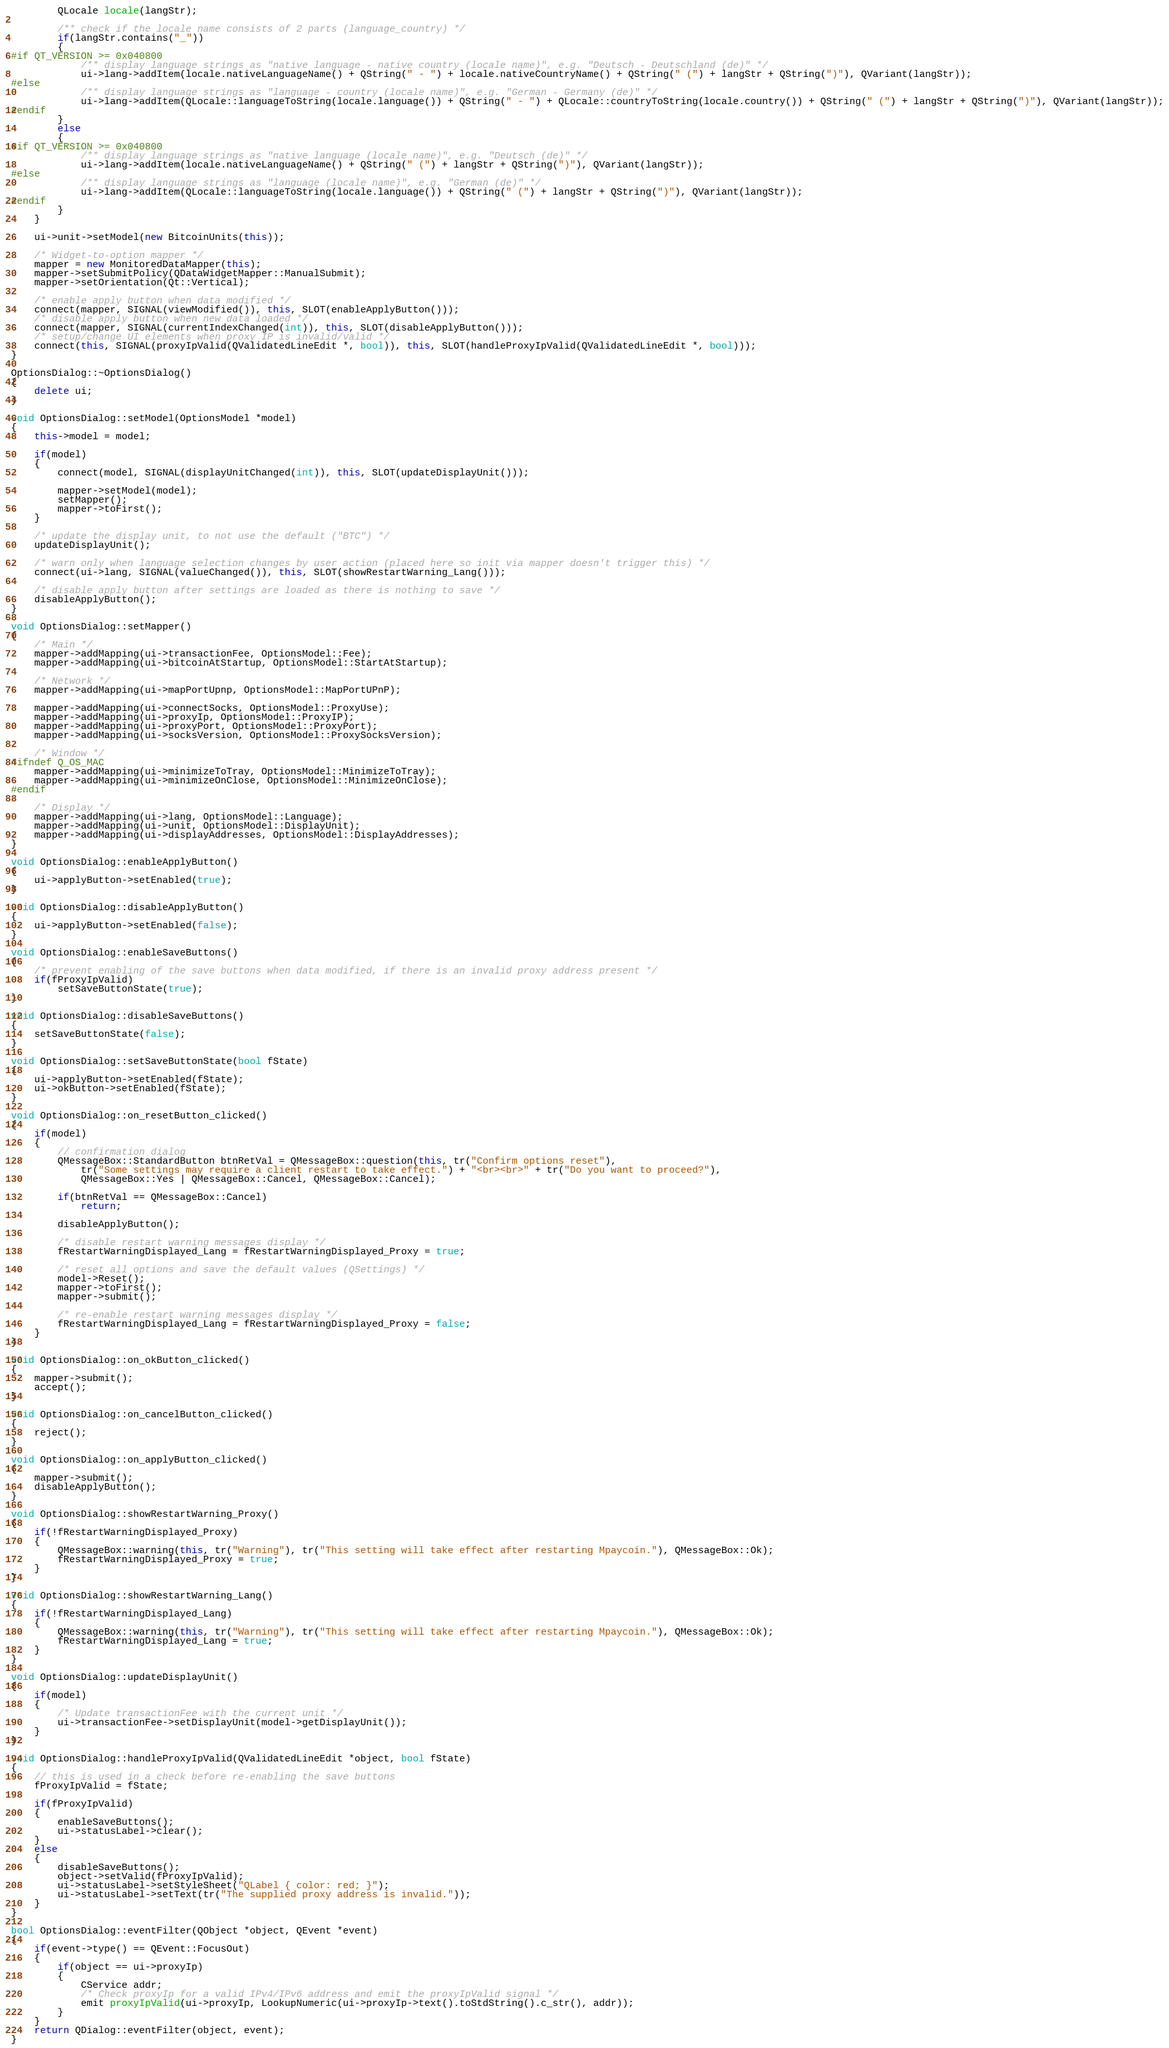<code> <loc_0><loc_0><loc_500><loc_500><_C++_>        QLocale locale(langStr);

        /** check if the locale name consists of 2 parts (language_country) */
        if(langStr.contains("_"))
        {
#if QT_VERSION >= 0x040800
            /** display language strings as "native language - native country (locale name)", e.g. "Deutsch - Deutschland (de)" */
            ui->lang->addItem(locale.nativeLanguageName() + QString(" - ") + locale.nativeCountryName() + QString(" (") + langStr + QString(")"), QVariant(langStr));
#else
            /** display language strings as "language - country (locale name)", e.g. "German - Germany (de)" */
            ui->lang->addItem(QLocale::languageToString(locale.language()) + QString(" - ") + QLocale::countryToString(locale.country()) + QString(" (") + langStr + QString(")"), QVariant(langStr));
#endif
        }
        else
        {
#if QT_VERSION >= 0x040800
            /** display language strings as "native language (locale name)", e.g. "Deutsch (de)" */
            ui->lang->addItem(locale.nativeLanguageName() + QString(" (") + langStr + QString(")"), QVariant(langStr));
#else
            /** display language strings as "language (locale name)", e.g. "German (de)" */
            ui->lang->addItem(QLocale::languageToString(locale.language()) + QString(" (") + langStr + QString(")"), QVariant(langStr));
#endif
        }
    }

    ui->unit->setModel(new BitcoinUnits(this));

    /* Widget-to-option mapper */
    mapper = new MonitoredDataMapper(this);
    mapper->setSubmitPolicy(QDataWidgetMapper::ManualSubmit);
    mapper->setOrientation(Qt::Vertical);

    /* enable apply button when data modified */
    connect(mapper, SIGNAL(viewModified()), this, SLOT(enableApplyButton()));
    /* disable apply button when new data loaded */
    connect(mapper, SIGNAL(currentIndexChanged(int)), this, SLOT(disableApplyButton()));
    /* setup/change UI elements when proxy IP is invalid/valid */
    connect(this, SIGNAL(proxyIpValid(QValidatedLineEdit *, bool)), this, SLOT(handleProxyIpValid(QValidatedLineEdit *, bool)));
}

OptionsDialog::~OptionsDialog()
{
    delete ui;
}

void OptionsDialog::setModel(OptionsModel *model)
{
    this->model = model;

    if(model)
    {
        connect(model, SIGNAL(displayUnitChanged(int)), this, SLOT(updateDisplayUnit()));

        mapper->setModel(model);
        setMapper();
        mapper->toFirst();
    }

    /* update the display unit, to not use the default ("BTC") */
    updateDisplayUnit();

    /* warn only when language selection changes by user action (placed here so init via mapper doesn't trigger this) */
    connect(ui->lang, SIGNAL(valueChanged()), this, SLOT(showRestartWarning_Lang()));

    /* disable apply button after settings are loaded as there is nothing to save */
    disableApplyButton();
}

void OptionsDialog::setMapper()
{
    /* Main */
    mapper->addMapping(ui->transactionFee, OptionsModel::Fee);
    mapper->addMapping(ui->bitcoinAtStartup, OptionsModel::StartAtStartup);

    /* Network */
    mapper->addMapping(ui->mapPortUpnp, OptionsModel::MapPortUPnP);

    mapper->addMapping(ui->connectSocks, OptionsModel::ProxyUse);
    mapper->addMapping(ui->proxyIp, OptionsModel::ProxyIP);
    mapper->addMapping(ui->proxyPort, OptionsModel::ProxyPort);
    mapper->addMapping(ui->socksVersion, OptionsModel::ProxySocksVersion);

    /* Window */
#ifndef Q_OS_MAC
    mapper->addMapping(ui->minimizeToTray, OptionsModel::MinimizeToTray);
    mapper->addMapping(ui->minimizeOnClose, OptionsModel::MinimizeOnClose);
#endif

    /* Display */
    mapper->addMapping(ui->lang, OptionsModel::Language);
    mapper->addMapping(ui->unit, OptionsModel::DisplayUnit);
    mapper->addMapping(ui->displayAddresses, OptionsModel::DisplayAddresses);
}

void OptionsDialog::enableApplyButton()
{
    ui->applyButton->setEnabled(true);
}

void OptionsDialog::disableApplyButton()
{
    ui->applyButton->setEnabled(false);
}

void OptionsDialog::enableSaveButtons()
{
    /* prevent enabling of the save buttons when data modified, if there is an invalid proxy address present */
    if(fProxyIpValid)
        setSaveButtonState(true);
}

void OptionsDialog::disableSaveButtons()
{
    setSaveButtonState(false);
}

void OptionsDialog::setSaveButtonState(bool fState)
{
    ui->applyButton->setEnabled(fState);
    ui->okButton->setEnabled(fState);
}

void OptionsDialog::on_resetButton_clicked()
{
    if(model)
    {
        // confirmation dialog
        QMessageBox::StandardButton btnRetVal = QMessageBox::question(this, tr("Confirm options reset"),
            tr("Some settings may require a client restart to take effect.") + "<br><br>" + tr("Do you want to proceed?"),
            QMessageBox::Yes | QMessageBox::Cancel, QMessageBox::Cancel);

        if(btnRetVal == QMessageBox::Cancel)
            return;

        disableApplyButton();

        /* disable restart warning messages display */
        fRestartWarningDisplayed_Lang = fRestartWarningDisplayed_Proxy = true;

        /* reset all options and save the default values (QSettings) */
        model->Reset();
        mapper->toFirst();
        mapper->submit();

        /* re-enable restart warning messages display */
        fRestartWarningDisplayed_Lang = fRestartWarningDisplayed_Proxy = false;
    }
}

void OptionsDialog::on_okButton_clicked()
{
    mapper->submit();
    accept();
}

void OptionsDialog::on_cancelButton_clicked()
{
    reject();
}

void OptionsDialog::on_applyButton_clicked()
{
    mapper->submit();
    disableApplyButton();
}

void OptionsDialog::showRestartWarning_Proxy()
{
    if(!fRestartWarningDisplayed_Proxy)
    {
        QMessageBox::warning(this, tr("Warning"), tr("This setting will take effect after restarting Mpaycoin."), QMessageBox::Ok);
        fRestartWarningDisplayed_Proxy = true;
    }
}

void OptionsDialog::showRestartWarning_Lang()
{
    if(!fRestartWarningDisplayed_Lang)
    {
        QMessageBox::warning(this, tr("Warning"), tr("This setting will take effect after restarting Mpaycoin."), QMessageBox::Ok);
        fRestartWarningDisplayed_Lang = true;
    }
}

void OptionsDialog::updateDisplayUnit()
{
    if(model)
    {
        /* Update transactionFee with the current unit */
        ui->transactionFee->setDisplayUnit(model->getDisplayUnit());
    }
}

void OptionsDialog::handleProxyIpValid(QValidatedLineEdit *object, bool fState)
{
    // this is used in a check before re-enabling the save buttons
    fProxyIpValid = fState;

    if(fProxyIpValid)
    {
        enableSaveButtons();
        ui->statusLabel->clear();
    }
    else
    {
        disableSaveButtons();
        object->setValid(fProxyIpValid);
        ui->statusLabel->setStyleSheet("QLabel { color: red; }");
        ui->statusLabel->setText(tr("The supplied proxy address is invalid."));
    }
}

bool OptionsDialog::eventFilter(QObject *object, QEvent *event)
{
    if(event->type() == QEvent::FocusOut)
    {
        if(object == ui->proxyIp)
        {
            CService addr;
            /* Check proxyIp for a valid IPv4/IPv6 address and emit the proxyIpValid signal */
            emit proxyIpValid(ui->proxyIp, LookupNumeric(ui->proxyIp->text().toStdString().c_str(), addr));
        }
    }
    return QDialog::eventFilter(object, event);
}
</code> 